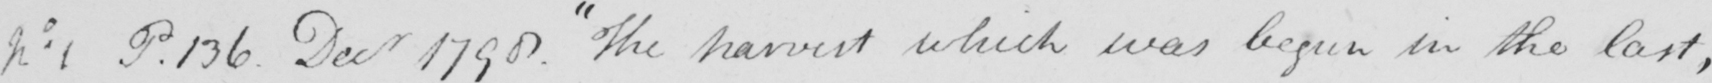Can you read and transcribe this handwriting? No 1 P . 136 . Decr 1790 . The harvest which was begun in the last , 